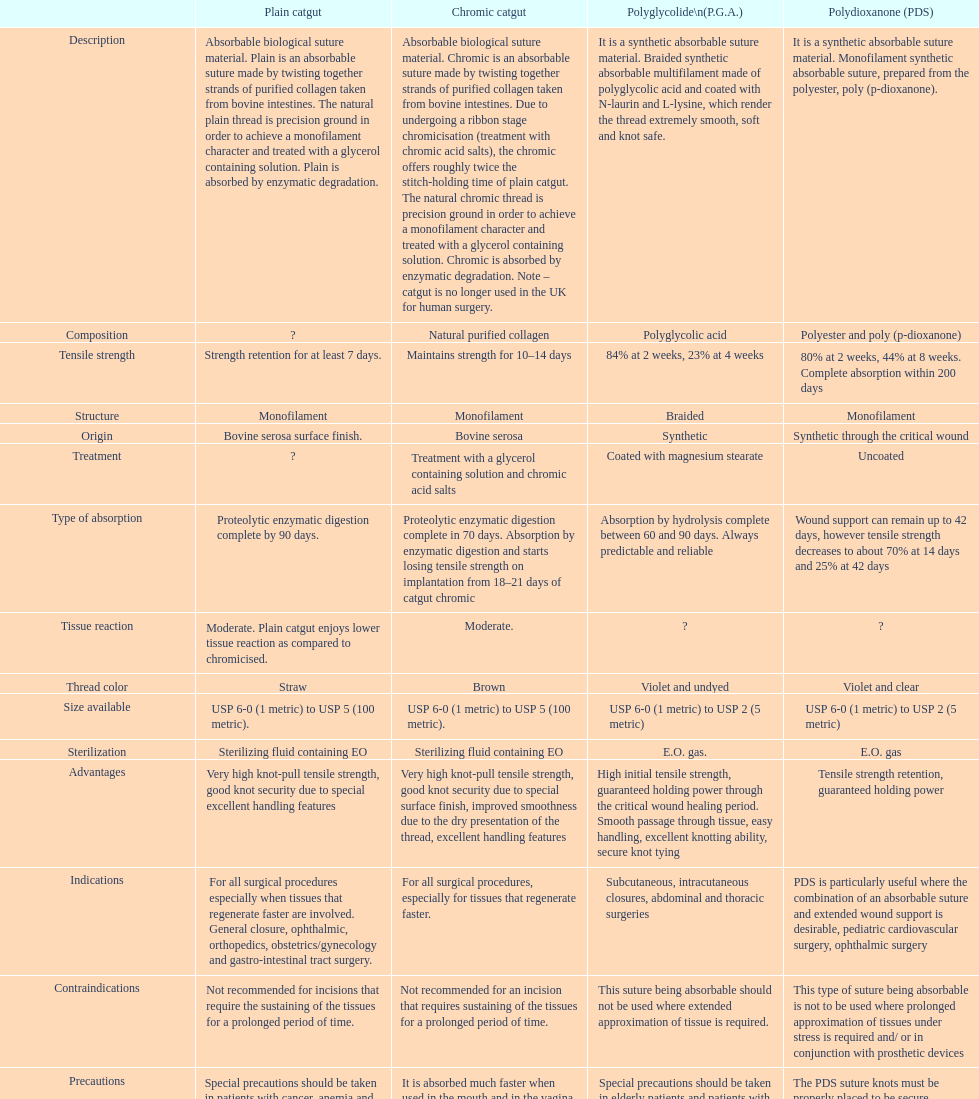Simple catgut and chromic catgut both possess what kind of architecture? Monofilament. 